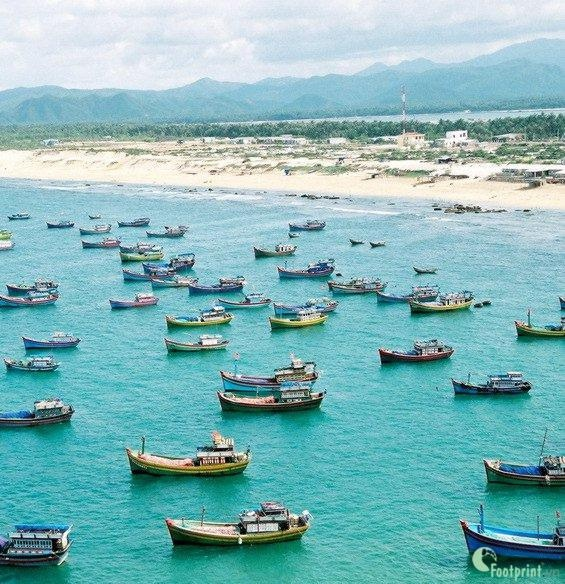Describe the objects in this image and their specific colors. I can see boat in lavender, teal, lightblue, and black tones, boat in lavender, black, lightgray, teal, and gray tones, boat in lavender, black, navy, and blue tones, boat in lavender, black, lightgray, and olive tones, and boat in lavender, black, gray, darkgreen, and teal tones in this image. 